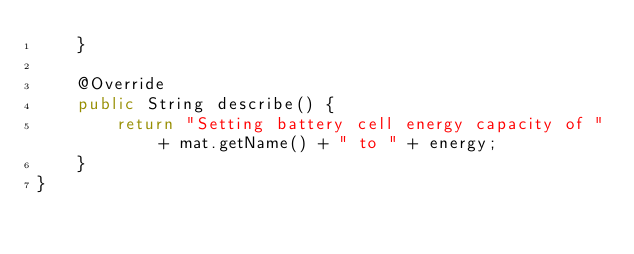Convert code to text. <code><loc_0><loc_0><loc_500><loc_500><_Java_>    }

    @Override
    public String describe() {
        return "Setting battery cell energy capacity of " + mat.getName() + " to " + energy;
    }
}
</code> 